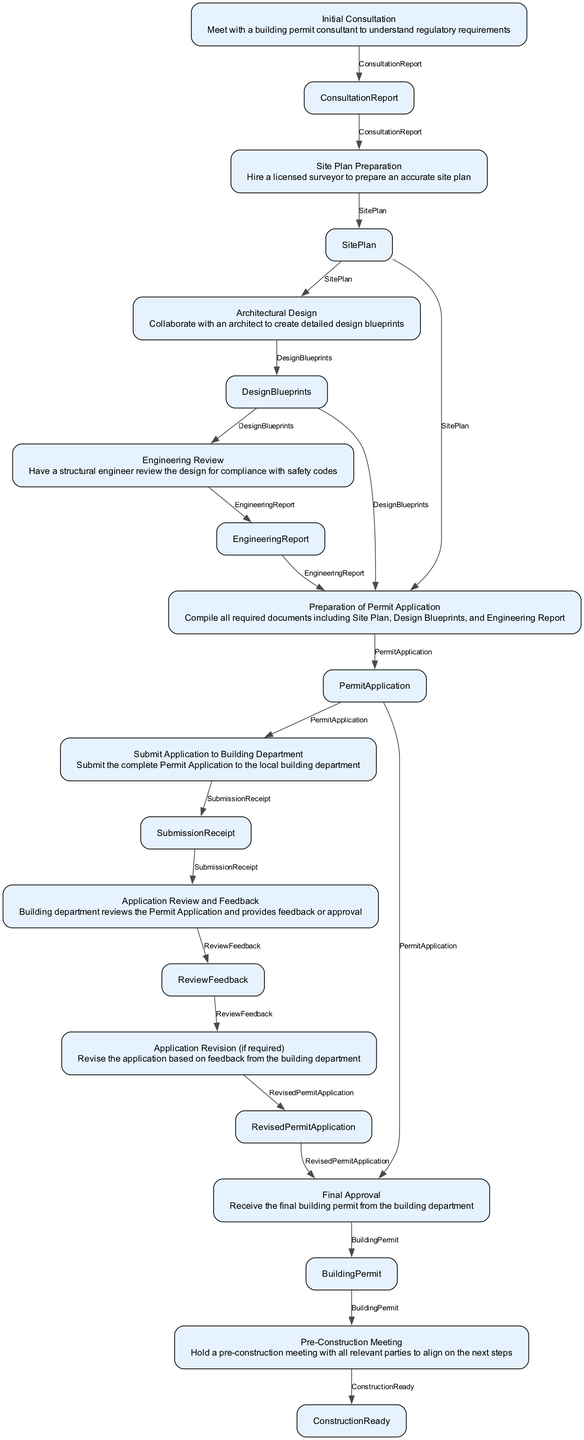What is the first step in the process? The diagram starts with the node "Initial Consultation", which outlines that the first step is to meet with a building permit consultant to understand regulatory requirements.
Answer: Initial Consultation How many nodes are in the diagram? By counting each distinct process represented, we find there are 10 nodes in total, representing the various steps in obtaining building permits and approvals.
Answer: 10 What is the output of the "Architectural Design" step? The output from the "Architectural Design" step is "DesignBlueprints", which is indicated as the result of collaborating with an architect to create detailed design blueprints.
Answer: DesignBlueprints Which steps require a revision based on feedback? The "Application Revision (if required)" step arises from the "Application Review and Feedback" node, which implies that revision is required when feedback from the building department suggests changes to the application.
Answer: Application Revision (if required) What does the "Final Approval" step require as input? The "Final Approval" step requires two inputs: "PermitApplication" and "RevisedPermitApplication", meaning both the original and revised applications contribute to achieving final approval.
Answer: PermitApplication, RevisedPermitApplication How does the process flow from "Submit Application to Building Department"? Upon completion of the "Submit Application to Building Department" step, it leads to the "Application Review and Feedback" step, indicating that submission prompts the review process and subsequent feedback from the building department.
Answer: Application Review and Feedback Which step directly follows "Pre-Construction Meeting"? The "Pre-Construction Meeting" step is the final step, which means there is no subsequent action that follows it in the context of this diagram.
Answer: None What is the main purpose of the "Engineering Review"? The purpose of the "Engineering Review" step is to have a structural engineer review the design for compliance with safety codes. Hence, its focus is primarily on ensuring the design meets necessary safety standards.
Answer: Compliance with safety codes What is the final output of the entire process? The final output after completing all necessary steps in the diagram is the "BuildingPermit", which signifies the authorized permit to start construction.
Answer: BuildingPermit 